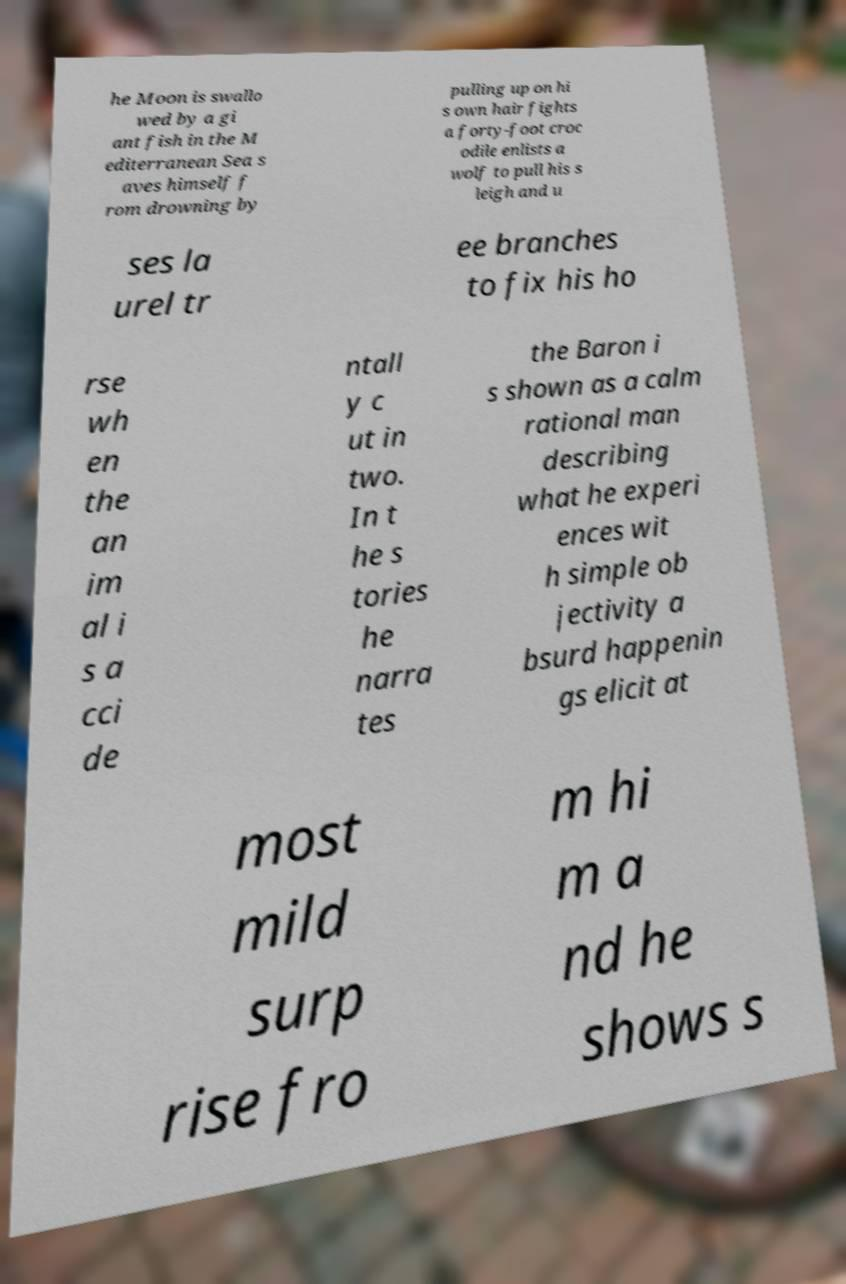Could you extract and type out the text from this image? he Moon is swallo wed by a gi ant fish in the M editerranean Sea s aves himself f rom drowning by pulling up on hi s own hair fights a forty-foot croc odile enlists a wolf to pull his s leigh and u ses la urel tr ee branches to fix his ho rse wh en the an im al i s a cci de ntall y c ut in two. In t he s tories he narra tes the Baron i s shown as a calm rational man describing what he experi ences wit h simple ob jectivity a bsurd happenin gs elicit at most mild surp rise fro m hi m a nd he shows s 